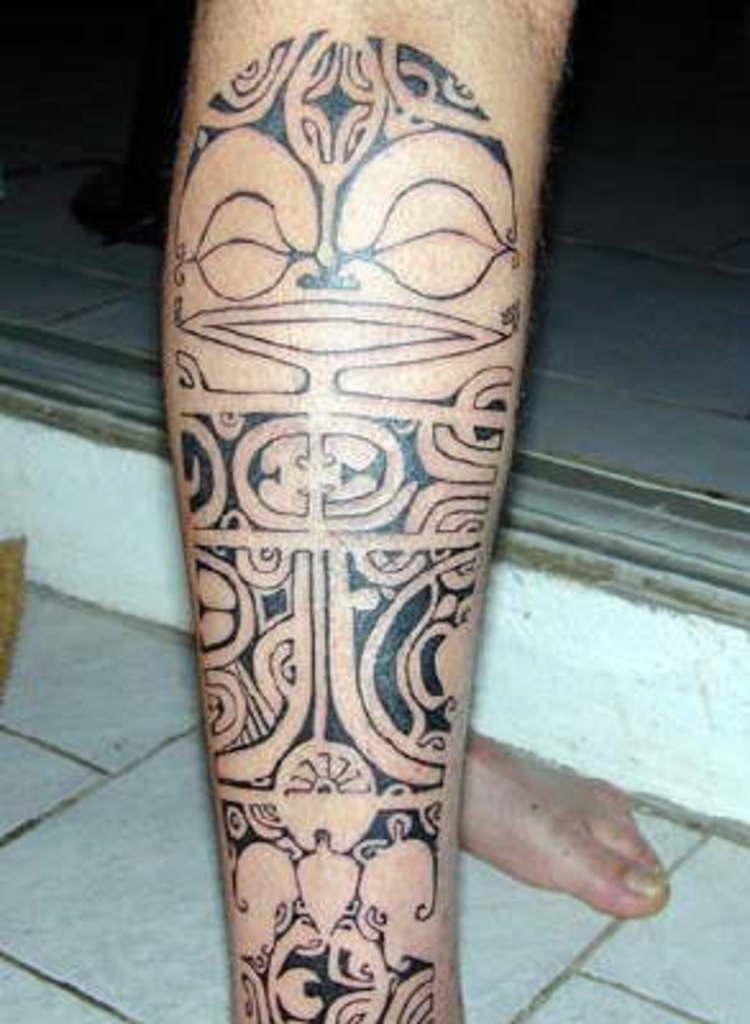How would you summarize this image in a sentence or two? This is a zoomed in picture. In the foreground we can see the leg of a person on which there is a black color tattoo. In the background we can see the ground and a foot of a person. 